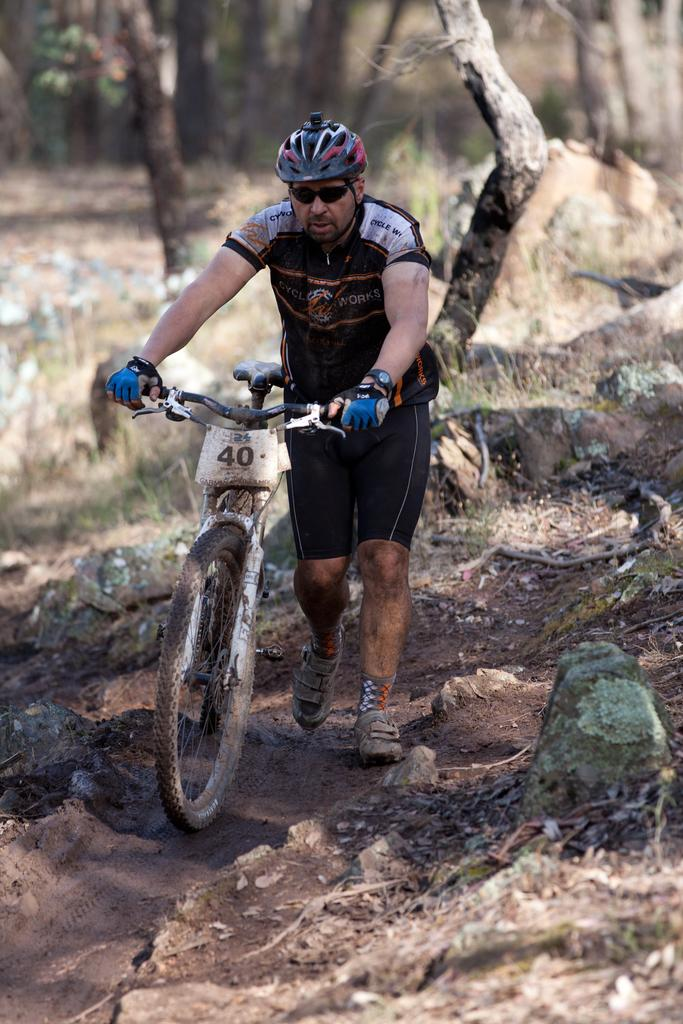Who is present in the image? There is a man in the image. What is the man holding in the image? The man is holding a bicycle. Where is the bicycle located in the image? The bicycle is in the middle of the image. What can be seen in the background of the image? There are trees and a grassy land in the background of the image. Is there any steam coming out of the bicycle in the image? No, there is no steam coming out of the bicycle in the image. 